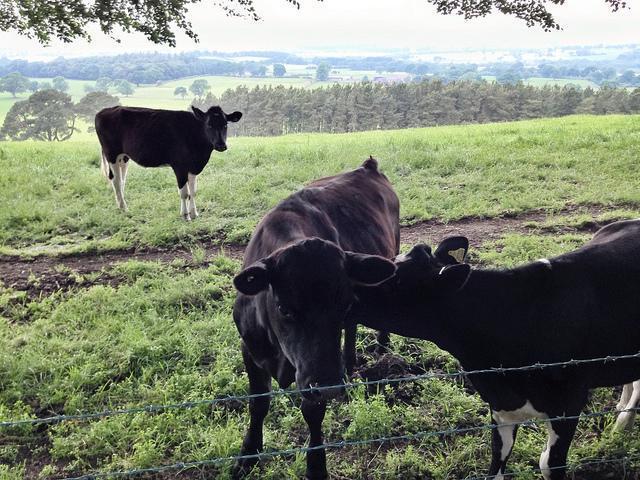How many cows are there?
Give a very brief answer. 3. How many people are in this photo?
Give a very brief answer. 0. 